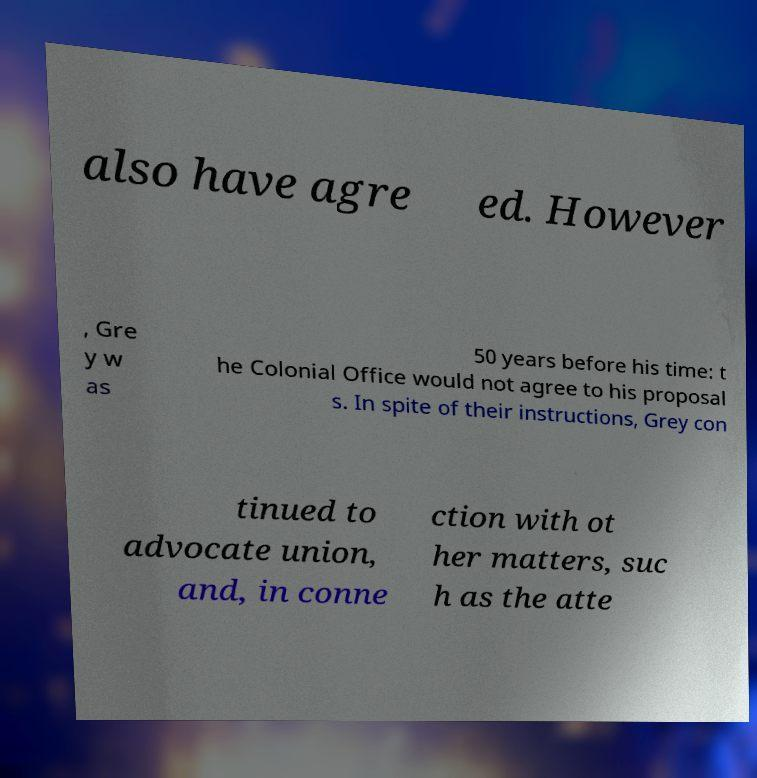Can you accurately transcribe the text from the provided image for me? also have agre ed. However , Gre y w as 50 years before his time: t he Colonial Office would not agree to his proposal s. In spite of their instructions, Grey con tinued to advocate union, and, in conne ction with ot her matters, suc h as the atte 